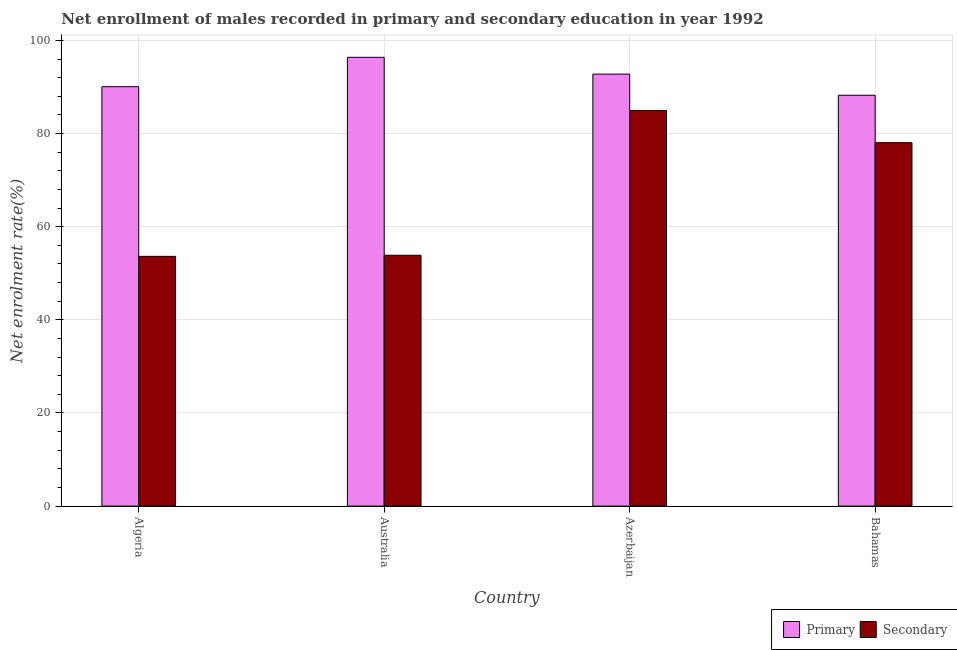How many different coloured bars are there?
Provide a succinct answer. 2. How many bars are there on the 2nd tick from the right?
Your answer should be very brief. 2. What is the label of the 1st group of bars from the left?
Your answer should be compact. Algeria. In how many cases, is the number of bars for a given country not equal to the number of legend labels?
Your answer should be very brief. 0. What is the enrollment rate in primary education in Australia?
Give a very brief answer. 96.38. Across all countries, what is the maximum enrollment rate in secondary education?
Your response must be concise. 84.95. Across all countries, what is the minimum enrollment rate in primary education?
Make the answer very short. 88.23. In which country was the enrollment rate in primary education maximum?
Your answer should be very brief. Australia. In which country was the enrollment rate in secondary education minimum?
Offer a terse response. Algeria. What is the total enrollment rate in secondary education in the graph?
Ensure brevity in your answer.  270.5. What is the difference between the enrollment rate in secondary education in Algeria and that in Australia?
Your answer should be very brief. -0.24. What is the difference between the enrollment rate in secondary education in Australia and the enrollment rate in primary education in Bahamas?
Offer a very short reply. -34.37. What is the average enrollment rate in secondary education per country?
Provide a short and direct response. 67.62. What is the difference between the enrollment rate in secondary education and enrollment rate in primary education in Australia?
Give a very brief answer. -42.51. In how many countries, is the enrollment rate in primary education greater than 88 %?
Provide a succinct answer. 4. What is the ratio of the enrollment rate in primary education in Algeria to that in Azerbaijan?
Provide a succinct answer. 0.97. Is the enrollment rate in secondary education in Australia less than that in Bahamas?
Provide a succinct answer. Yes. Is the difference between the enrollment rate in primary education in Australia and Azerbaijan greater than the difference between the enrollment rate in secondary education in Australia and Azerbaijan?
Offer a terse response. Yes. What is the difference between the highest and the second highest enrollment rate in secondary education?
Ensure brevity in your answer.  6.89. What is the difference between the highest and the lowest enrollment rate in secondary education?
Your answer should be very brief. 31.31. In how many countries, is the enrollment rate in primary education greater than the average enrollment rate in primary education taken over all countries?
Your answer should be compact. 2. Is the sum of the enrollment rate in primary education in Australia and Azerbaijan greater than the maximum enrollment rate in secondary education across all countries?
Keep it short and to the point. Yes. What does the 2nd bar from the left in Australia represents?
Offer a terse response. Secondary. What does the 1st bar from the right in Australia represents?
Your answer should be compact. Secondary. How many bars are there?
Ensure brevity in your answer.  8. Are all the bars in the graph horizontal?
Give a very brief answer. No. How many countries are there in the graph?
Make the answer very short. 4. Does the graph contain any zero values?
Offer a very short reply. No. Does the graph contain grids?
Offer a very short reply. Yes. How many legend labels are there?
Provide a succinct answer. 2. What is the title of the graph?
Make the answer very short. Net enrollment of males recorded in primary and secondary education in year 1992. Does "Private funds" appear as one of the legend labels in the graph?
Give a very brief answer. No. What is the label or title of the X-axis?
Offer a very short reply. Country. What is the label or title of the Y-axis?
Keep it short and to the point. Net enrolment rate(%). What is the Net enrolment rate(%) of Primary in Algeria?
Offer a terse response. 90.07. What is the Net enrolment rate(%) of Secondary in Algeria?
Your response must be concise. 53.63. What is the Net enrolment rate(%) of Primary in Australia?
Ensure brevity in your answer.  96.38. What is the Net enrolment rate(%) in Secondary in Australia?
Provide a short and direct response. 53.87. What is the Net enrolment rate(%) in Primary in Azerbaijan?
Offer a very short reply. 92.77. What is the Net enrolment rate(%) of Secondary in Azerbaijan?
Your response must be concise. 84.95. What is the Net enrolment rate(%) of Primary in Bahamas?
Give a very brief answer. 88.23. What is the Net enrolment rate(%) of Secondary in Bahamas?
Provide a short and direct response. 78.05. Across all countries, what is the maximum Net enrolment rate(%) in Primary?
Your answer should be compact. 96.38. Across all countries, what is the maximum Net enrolment rate(%) in Secondary?
Offer a terse response. 84.95. Across all countries, what is the minimum Net enrolment rate(%) in Primary?
Your answer should be compact. 88.23. Across all countries, what is the minimum Net enrolment rate(%) in Secondary?
Keep it short and to the point. 53.63. What is the total Net enrolment rate(%) in Primary in the graph?
Make the answer very short. 367.46. What is the total Net enrolment rate(%) in Secondary in the graph?
Your answer should be very brief. 270.5. What is the difference between the Net enrolment rate(%) in Primary in Algeria and that in Australia?
Provide a short and direct response. -6.31. What is the difference between the Net enrolment rate(%) in Secondary in Algeria and that in Australia?
Provide a succinct answer. -0.24. What is the difference between the Net enrolment rate(%) of Primary in Algeria and that in Azerbaijan?
Offer a terse response. -2.7. What is the difference between the Net enrolment rate(%) of Secondary in Algeria and that in Azerbaijan?
Keep it short and to the point. -31.31. What is the difference between the Net enrolment rate(%) in Primary in Algeria and that in Bahamas?
Make the answer very short. 1.84. What is the difference between the Net enrolment rate(%) of Secondary in Algeria and that in Bahamas?
Ensure brevity in your answer.  -24.42. What is the difference between the Net enrolment rate(%) in Primary in Australia and that in Azerbaijan?
Give a very brief answer. 3.61. What is the difference between the Net enrolment rate(%) of Secondary in Australia and that in Azerbaijan?
Provide a succinct answer. -31.08. What is the difference between the Net enrolment rate(%) in Primary in Australia and that in Bahamas?
Provide a succinct answer. 8.14. What is the difference between the Net enrolment rate(%) in Secondary in Australia and that in Bahamas?
Your answer should be compact. -24.18. What is the difference between the Net enrolment rate(%) in Primary in Azerbaijan and that in Bahamas?
Make the answer very short. 4.54. What is the difference between the Net enrolment rate(%) in Secondary in Azerbaijan and that in Bahamas?
Provide a succinct answer. 6.89. What is the difference between the Net enrolment rate(%) in Primary in Algeria and the Net enrolment rate(%) in Secondary in Australia?
Offer a terse response. 36.2. What is the difference between the Net enrolment rate(%) in Primary in Algeria and the Net enrolment rate(%) in Secondary in Azerbaijan?
Keep it short and to the point. 5.13. What is the difference between the Net enrolment rate(%) in Primary in Algeria and the Net enrolment rate(%) in Secondary in Bahamas?
Your answer should be compact. 12.02. What is the difference between the Net enrolment rate(%) in Primary in Australia and the Net enrolment rate(%) in Secondary in Azerbaijan?
Offer a terse response. 11.43. What is the difference between the Net enrolment rate(%) of Primary in Australia and the Net enrolment rate(%) of Secondary in Bahamas?
Provide a succinct answer. 18.33. What is the difference between the Net enrolment rate(%) in Primary in Azerbaijan and the Net enrolment rate(%) in Secondary in Bahamas?
Your answer should be compact. 14.72. What is the average Net enrolment rate(%) of Primary per country?
Provide a short and direct response. 91.86. What is the average Net enrolment rate(%) in Secondary per country?
Your answer should be compact. 67.62. What is the difference between the Net enrolment rate(%) in Primary and Net enrolment rate(%) in Secondary in Algeria?
Provide a short and direct response. 36.44. What is the difference between the Net enrolment rate(%) of Primary and Net enrolment rate(%) of Secondary in Australia?
Keep it short and to the point. 42.51. What is the difference between the Net enrolment rate(%) in Primary and Net enrolment rate(%) in Secondary in Azerbaijan?
Ensure brevity in your answer.  7.83. What is the difference between the Net enrolment rate(%) in Primary and Net enrolment rate(%) in Secondary in Bahamas?
Your answer should be very brief. 10.18. What is the ratio of the Net enrolment rate(%) of Primary in Algeria to that in Australia?
Give a very brief answer. 0.93. What is the ratio of the Net enrolment rate(%) of Primary in Algeria to that in Azerbaijan?
Your response must be concise. 0.97. What is the ratio of the Net enrolment rate(%) of Secondary in Algeria to that in Azerbaijan?
Make the answer very short. 0.63. What is the ratio of the Net enrolment rate(%) of Primary in Algeria to that in Bahamas?
Offer a very short reply. 1.02. What is the ratio of the Net enrolment rate(%) in Secondary in Algeria to that in Bahamas?
Your answer should be very brief. 0.69. What is the ratio of the Net enrolment rate(%) in Primary in Australia to that in Azerbaijan?
Your answer should be compact. 1.04. What is the ratio of the Net enrolment rate(%) of Secondary in Australia to that in Azerbaijan?
Give a very brief answer. 0.63. What is the ratio of the Net enrolment rate(%) of Primary in Australia to that in Bahamas?
Offer a terse response. 1.09. What is the ratio of the Net enrolment rate(%) of Secondary in Australia to that in Bahamas?
Your answer should be compact. 0.69. What is the ratio of the Net enrolment rate(%) in Primary in Azerbaijan to that in Bahamas?
Offer a terse response. 1.05. What is the ratio of the Net enrolment rate(%) of Secondary in Azerbaijan to that in Bahamas?
Offer a very short reply. 1.09. What is the difference between the highest and the second highest Net enrolment rate(%) of Primary?
Your answer should be compact. 3.61. What is the difference between the highest and the second highest Net enrolment rate(%) in Secondary?
Keep it short and to the point. 6.89. What is the difference between the highest and the lowest Net enrolment rate(%) of Primary?
Keep it short and to the point. 8.14. What is the difference between the highest and the lowest Net enrolment rate(%) in Secondary?
Keep it short and to the point. 31.31. 